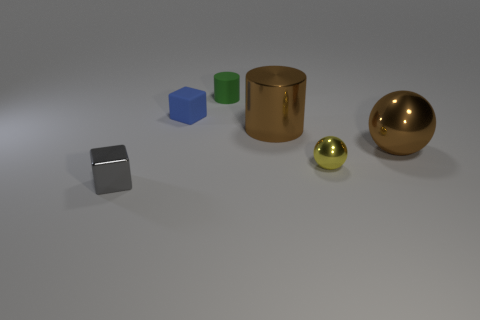Describe the lighting and mood of the scene. The lighting in the scene is soft and diffused, casting gentle shadows on the surface, which contributes to a calm and neutral mood in the image. 